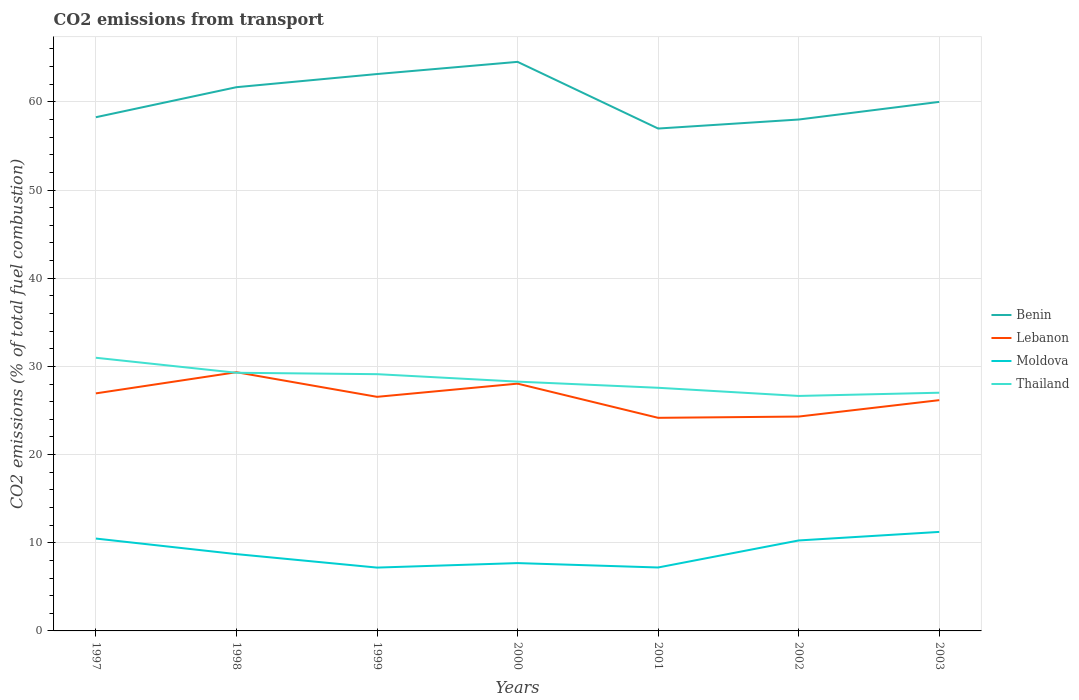How many different coloured lines are there?
Give a very brief answer. 4. Across all years, what is the maximum total CO2 emitted in Benin?
Make the answer very short. 56.98. In which year was the total CO2 emitted in Lebanon maximum?
Give a very brief answer. 2001. What is the total total CO2 emitted in Benin in the graph?
Ensure brevity in your answer.  3.16. What is the difference between the highest and the second highest total CO2 emitted in Benin?
Keep it short and to the point. 7.56. What is the difference between the highest and the lowest total CO2 emitted in Thailand?
Your response must be concise. 3. Is the total CO2 emitted in Thailand strictly greater than the total CO2 emitted in Lebanon over the years?
Your answer should be compact. No. How many years are there in the graph?
Provide a succinct answer. 7. What is the difference between two consecutive major ticks on the Y-axis?
Give a very brief answer. 10. Are the values on the major ticks of Y-axis written in scientific E-notation?
Give a very brief answer. No. Does the graph contain any zero values?
Give a very brief answer. No. Does the graph contain grids?
Your answer should be compact. Yes. Where does the legend appear in the graph?
Your response must be concise. Center right. How many legend labels are there?
Give a very brief answer. 4. What is the title of the graph?
Provide a short and direct response. CO2 emissions from transport. What is the label or title of the Y-axis?
Give a very brief answer. CO2 emissions (% of total fuel combustion). What is the CO2 emissions (% of total fuel combustion) of Benin in 1997?
Keep it short and to the point. 58.26. What is the CO2 emissions (% of total fuel combustion) in Lebanon in 1997?
Keep it short and to the point. 26.94. What is the CO2 emissions (% of total fuel combustion) of Moldova in 1997?
Provide a short and direct response. 10.48. What is the CO2 emissions (% of total fuel combustion) in Thailand in 1997?
Give a very brief answer. 30.98. What is the CO2 emissions (% of total fuel combustion) in Benin in 1998?
Your response must be concise. 61.67. What is the CO2 emissions (% of total fuel combustion) in Lebanon in 1998?
Give a very brief answer. 29.34. What is the CO2 emissions (% of total fuel combustion) in Moldova in 1998?
Your answer should be compact. 8.71. What is the CO2 emissions (% of total fuel combustion) in Thailand in 1998?
Make the answer very short. 29.28. What is the CO2 emissions (% of total fuel combustion) of Benin in 1999?
Your answer should be very brief. 63.16. What is the CO2 emissions (% of total fuel combustion) in Lebanon in 1999?
Provide a succinct answer. 26.55. What is the CO2 emissions (% of total fuel combustion) of Moldova in 1999?
Ensure brevity in your answer.  7.18. What is the CO2 emissions (% of total fuel combustion) in Thailand in 1999?
Ensure brevity in your answer.  29.12. What is the CO2 emissions (% of total fuel combustion) in Benin in 2000?
Your response must be concise. 64.54. What is the CO2 emissions (% of total fuel combustion) in Lebanon in 2000?
Ensure brevity in your answer.  28.05. What is the CO2 emissions (% of total fuel combustion) in Moldova in 2000?
Ensure brevity in your answer.  7.69. What is the CO2 emissions (% of total fuel combustion) in Thailand in 2000?
Provide a short and direct response. 28.27. What is the CO2 emissions (% of total fuel combustion) of Benin in 2001?
Make the answer very short. 56.98. What is the CO2 emissions (% of total fuel combustion) of Lebanon in 2001?
Offer a terse response. 24.17. What is the CO2 emissions (% of total fuel combustion) in Moldova in 2001?
Your answer should be very brief. 7.2. What is the CO2 emissions (% of total fuel combustion) of Thailand in 2001?
Your response must be concise. 27.58. What is the CO2 emissions (% of total fuel combustion) in Lebanon in 2002?
Provide a succinct answer. 24.31. What is the CO2 emissions (% of total fuel combustion) in Moldova in 2002?
Ensure brevity in your answer.  10.26. What is the CO2 emissions (% of total fuel combustion) of Thailand in 2002?
Your answer should be compact. 26.65. What is the CO2 emissions (% of total fuel combustion) of Lebanon in 2003?
Make the answer very short. 26.17. What is the CO2 emissions (% of total fuel combustion) in Moldova in 2003?
Offer a terse response. 11.23. What is the CO2 emissions (% of total fuel combustion) of Thailand in 2003?
Give a very brief answer. 27.02. Across all years, what is the maximum CO2 emissions (% of total fuel combustion) in Benin?
Make the answer very short. 64.54. Across all years, what is the maximum CO2 emissions (% of total fuel combustion) in Lebanon?
Offer a terse response. 29.34. Across all years, what is the maximum CO2 emissions (% of total fuel combustion) of Moldova?
Offer a very short reply. 11.23. Across all years, what is the maximum CO2 emissions (% of total fuel combustion) of Thailand?
Ensure brevity in your answer.  30.98. Across all years, what is the minimum CO2 emissions (% of total fuel combustion) of Benin?
Provide a short and direct response. 56.98. Across all years, what is the minimum CO2 emissions (% of total fuel combustion) of Lebanon?
Your answer should be compact. 24.17. Across all years, what is the minimum CO2 emissions (% of total fuel combustion) in Moldova?
Offer a terse response. 7.18. Across all years, what is the minimum CO2 emissions (% of total fuel combustion) in Thailand?
Keep it short and to the point. 26.65. What is the total CO2 emissions (% of total fuel combustion) of Benin in the graph?
Give a very brief answer. 422.6. What is the total CO2 emissions (% of total fuel combustion) of Lebanon in the graph?
Make the answer very short. 185.53. What is the total CO2 emissions (% of total fuel combustion) in Moldova in the graph?
Give a very brief answer. 62.75. What is the total CO2 emissions (% of total fuel combustion) in Thailand in the graph?
Give a very brief answer. 198.89. What is the difference between the CO2 emissions (% of total fuel combustion) of Benin in 1997 and that in 1998?
Your answer should be very brief. -3.41. What is the difference between the CO2 emissions (% of total fuel combustion) in Lebanon in 1997 and that in 1998?
Your answer should be very brief. -2.4. What is the difference between the CO2 emissions (% of total fuel combustion) of Moldova in 1997 and that in 1998?
Your response must be concise. 1.76. What is the difference between the CO2 emissions (% of total fuel combustion) of Thailand in 1997 and that in 1998?
Your answer should be compact. 1.7. What is the difference between the CO2 emissions (% of total fuel combustion) of Benin in 1997 and that in 1999?
Offer a terse response. -4.9. What is the difference between the CO2 emissions (% of total fuel combustion) of Lebanon in 1997 and that in 1999?
Provide a short and direct response. 0.39. What is the difference between the CO2 emissions (% of total fuel combustion) of Moldova in 1997 and that in 1999?
Offer a terse response. 3.29. What is the difference between the CO2 emissions (% of total fuel combustion) of Thailand in 1997 and that in 1999?
Offer a very short reply. 1.86. What is the difference between the CO2 emissions (% of total fuel combustion) of Benin in 1997 and that in 2000?
Your answer should be very brief. -6.28. What is the difference between the CO2 emissions (% of total fuel combustion) in Lebanon in 1997 and that in 2000?
Your answer should be compact. -1.1. What is the difference between the CO2 emissions (% of total fuel combustion) of Moldova in 1997 and that in 2000?
Your answer should be compact. 2.78. What is the difference between the CO2 emissions (% of total fuel combustion) in Thailand in 1997 and that in 2000?
Provide a short and direct response. 2.71. What is the difference between the CO2 emissions (% of total fuel combustion) in Benin in 1997 and that in 2001?
Make the answer very short. 1.28. What is the difference between the CO2 emissions (% of total fuel combustion) of Lebanon in 1997 and that in 2001?
Ensure brevity in your answer.  2.77. What is the difference between the CO2 emissions (% of total fuel combustion) in Moldova in 1997 and that in 2001?
Give a very brief answer. 3.28. What is the difference between the CO2 emissions (% of total fuel combustion) of Thailand in 1997 and that in 2001?
Your answer should be very brief. 3.4. What is the difference between the CO2 emissions (% of total fuel combustion) of Benin in 1997 and that in 2002?
Provide a succinct answer. 0.26. What is the difference between the CO2 emissions (% of total fuel combustion) in Lebanon in 1997 and that in 2002?
Provide a short and direct response. 2.63. What is the difference between the CO2 emissions (% of total fuel combustion) in Moldova in 1997 and that in 2002?
Offer a very short reply. 0.21. What is the difference between the CO2 emissions (% of total fuel combustion) of Thailand in 1997 and that in 2002?
Make the answer very short. 4.33. What is the difference between the CO2 emissions (% of total fuel combustion) of Benin in 1997 and that in 2003?
Offer a very short reply. -1.74. What is the difference between the CO2 emissions (% of total fuel combustion) of Lebanon in 1997 and that in 2003?
Your answer should be very brief. 0.77. What is the difference between the CO2 emissions (% of total fuel combustion) of Moldova in 1997 and that in 2003?
Give a very brief answer. -0.75. What is the difference between the CO2 emissions (% of total fuel combustion) in Thailand in 1997 and that in 2003?
Offer a terse response. 3.96. What is the difference between the CO2 emissions (% of total fuel combustion) in Benin in 1998 and that in 1999?
Offer a terse response. -1.49. What is the difference between the CO2 emissions (% of total fuel combustion) of Lebanon in 1998 and that in 1999?
Make the answer very short. 2.79. What is the difference between the CO2 emissions (% of total fuel combustion) of Moldova in 1998 and that in 1999?
Provide a short and direct response. 1.53. What is the difference between the CO2 emissions (% of total fuel combustion) of Thailand in 1998 and that in 1999?
Make the answer very short. 0.16. What is the difference between the CO2 emissions (% of total fuel combustion) of Benin in 1998 and that in 2000?
Provide a short and direct response. -2.87. What is the difference between the CO2 emissions (% of total fuel combustion) of Lebanon in 1998 and that in 2000?
Your response must be concise. 1.3. What is the difference between the CO2 emissions (% of total fuel combustion) of Moldova in 1998 and that in 2000?
Offer a very short reply. 1.02. What is the difference between the CO2 emissions (% of total fuel combustion) in Thailand in 1998 and that in 2000?
Offer a terse response. 1. What is the difference between the CO2 emissions (% of total fuel combustion) of Benin in 1998 and that in 2001?
Offer a terse response. 4.69. What is the difference between the CO2 emissions (% of total fuel combustion) of Lebanon in 1998 and that in 2001?
Your response must be concise. 5.17. What is the difference between the CO2 emissions (% of total fuel combustion) of Moldova in 1998 and that in 2001?
Give a very brief answer. 1.52. What is the difference between the CO2 emissions (% of total fuel combustion) of Thailand in 1998 and that in 2001?
Provide a short and direct response. 1.7. What is the difference between the CO2 emissions (% of total fuel combustion) in Benin in 1998 and that in 2002?
Keep it short and to the point. 3.67. What is the difference between the CO2 emissions (% of total fuel combustion) in Lebanon in 1998 and that in 2002?
Ensure brevity in your answer.  5.03. What is the difference between the CO2 emissions (% of total fuel combustion) of Moldova in 1998 and that in 2002?
Offer a very short reply. -1.55. What is the difference between the CO2 emissions (% of total fuel combustion) in Thailand in 1998 and that in 2002?
Your response must be concise. 2.63. What is the difference between the CO2 emissions (% of total fuel combustion) in Lebanon in 1998 and that in 2003?
Offer a very short reply. 3.17. What is the difference between the CO2 emissions (% of total fuel combustion) of Moldova in 1998 and that in 2003?
Ensure brevity in your answer.  -2.52. What is the difference between the CO2 emissions (% of total fuel combustion) in Thailand in 1998 and that in 2003?
Make the answer very short. 2.26. What is the difference between the CO2 emissions (% of total fuel combustion) of Benin in 1999 and that in 2000?
Your response must be concise. -1.38. What is the difference between the CO2 emissions (% of total fuel combustion) in Lebanon in 1999 and that in 2000?
Provide a succinct answer. -1.5. What is the difference between the CO2 emissions (% of total fuel combustion) of Moldova in 1999 and that in 2000?
Make the answer very short. -0.51. What is the difference between the CO2 emissions (% of total fuel combustion) in Thailand in 1999 and that in 2000?
Your answer should be compact. 0.85. What is the difference between the CO2 emissions (% of total fuel combustion) in Benin in 1999 and that in 2001?
Provide a succinct answer. 6.18. What is the difference between the CO2 emissions (% of total fuel combustion) in Lebanon in 1999 and that in 2001?
Your answer should be very brief. 2.38. What is the difference between the CO2 emissions (% of total fuel combustion) in Moldova in 1999 and that in 2001?
Your response must be concise. -0.01. What is the difference between the CO2 emissions (% of total fuel combustion) in Thailand in 1999 and that in 2001?
Keep it short and to the point. 1.54. What is the difference between the CO2 emissions (% of total fuel combustion) of Benin in 1999 and that in 2002?
Offer a very short reply. 5.16. What is the difference between the CO2 emissions (% of total fuel combustion) in Lebanon in 1999 and that in 2002?
Your response must be concise. 2.24. What is the difference between the CO2 emissions (% of total fuel combustion) of Moldova in 1999 and that in 2002?
Ensure brevity in your answer.  -3.08. What is the difference between the CO2 emissions (% of total fuel combustion) of Thailand in 1999 and that in 2002?
Your answer should be compact. 2.47. What is the difference between the CO2 emissions (% of total fuel combustion) of Benin in 1999 and that in 2003?
Provide a short and direct response. 3.16. What is the difference between the CO2 emissions (% of total fuel combustion) in Lebanon in 1999 and that in 2003?
Your answer should be very brief. 0.38. What is the difference between the CO2 emissions (% of total fuel combustion) of Moldova in 1999 and that in 2003?
Provide a short and direct response. -4.05. What is the difference between the CO2 emissions (% of total fuel combustion) in Thailand in 1999 and that in 2003?
Give a very brief answer. 2.1. What is the difference between the CO2 emissions (% of total fuel combustion) of Benin in 2000 and that in 2001?
Ensure brevity in your answer.  7.56. What is the difference between the CO2 emissions (% of total fuel combustion) in Lebanon in 2000 and that in 2001?
Give a very brief answer. 3.88. What is the difference between the CO2 emissions (% of total fuel combustion) in Moldova in 2000 and that in 2001?
Offer a terse response. 0.5. What is the difference between the CO2 emissions (% of total fuel combustion) in Thailand in 2000 and that in 2001?
Your answer should be compact. 0.7. What is the difference between the CO2 emissions (% of total fuel combustion) in Benin in 2000 and that in 2002?
Keep it short and to the point. 6.54. What is the difference between the CO2 emissions (% of total fuel combustion) of Lebanon in 2000 and that in 2002?
Your answer should be compact. 3.73. What is the difference between the CO2 emissions (% of total fuel combustion) in Moldova in 2000 and that in 2002?
Ensure brevity in your answer.  -2.57. What is the difference between the CO2 emissions (% of total fuel combustion) of Thailand in 2000 and that in 2002?
Offer a terse response. 1.62. What is the difference between the CO2 emissions (% of total fuel combustion) of Benin in 2000 and that in 2003?
Your response must be concise. 4.54. What is the difference between the CO2 emissions (% of total fuel combustion) in Lebanon in 2000 and that in 2003?
Your answer should be very brief. 1.87. What is the difference between the CO2 emissions (% of total fuel combustion) in Moldova in 2000 and that in 2003?
Your response must be concise. -3.54. What is the difference between the CO2 emissions (% of total fuel combustion) in Thailand in 2000 and that in 2003?
Your answer should be very brief. 1.26. What is the difference between the CO2 emissions (% of total fuel combustion) of Benin in 2001 and that in 2002?
Offer a very short reply. -1.02. What is the difference between the CO2 emissions (% of total fuel combustion) of Lebanon in 2001 and that in 2002?
Your answer should be compact. -0.14. What is the difference between the CO2 emissions (% of total fuel combustion) in Moldova in 2001 and that in 2002?
Provide a succinct answer. -3.06. What is the difference between the CO2 emissions (% of total fuel combustion) of Thailand in 2001 and that in 2002?
Your answer should be very brief. 0.93. What is the difference between the CO2 emissions (% of total fuel combustion) of Benin in 2001 and that in 2003?
Your answer should be compact. -3.02. What is the difference between the CO2 emissions (% of total fuel combustion) in Lebanon in 2001 and that in 2003?
Your answer should be compact. -2.01. What is the difference between the CO2 emissions (% of total fuel combustion) of Moldova in 2001 and that in 2003?
Your response must be concise. -4.03. What is the difference between the CO2 emissions (% of total fuel combustion) in Thailand in 2001 and that in 2003?
Provide a short and direct response. 0.56. What is the difference between the CO2 emissions (% of total fuel combustion) in Lebanon in 2002 and that in 2003?
Provide a succinct answer. -1.86. What is the difference between the CO2 emissions (% of total fuel combustion) in Moldova in 2002 and that in 2003?
Offer a terse response. -0.97. What is the difference between the CO2 emissions (% of total fuel combustion) in Thailand in 2002 and that in 2003?
Offer a very short reply. -0.36. What is the difference between the CO2 emissions (% of total fuel combustion) of Benin in 1997 and the CO2 emissions (% of total fuel combustion) of Lebanon in 1998?
Your response must be concise. 28.92. What is the difference between the CO2 emissions (% of total fuel combustion) in Benin in 1997 and the CO2 emissions (% of total fuel combustion) in Moldova in 1998?
Ensure brevity in your answer.  49.55. What is the difference between the CO2 emissions (% of total fuel combustion) of Benin in 1997 and the CO2 emissions (% of total fuel combustion) of Thailand in 1998?
Provide a succinct answer. 28.98. What is the difference between the CO2 emissions (% of total fuel combustion) of Lebanon in 1997 and the CO2 emissions (% of total fuel combustion) of Moldova in 1998?
Your answer should be very brief. 18.23. What is the difference between the CO2 emissions (% of total fuel combustion) in Lebanon in 1997 and the CO2 emissions (% of total fuel combustion) in Thailand in 1998?
Keep it short and to the point. -2.34. What is the difference between the CO2 emissions (% of total fuel combustion) in Moldova in 1997 and the CO2 emissions (% of total fuel combustion) in Thailand in 1998?
Provide a succinct answer. -18.8. What is the difference between the CO2 emissions (% of total fuel combustion) in Benin in 1997 and the CO2 emissions (% of total fuel combustion) in Lebanon in 1999?
Make the answer very short. 31.71. What is the difference between the CO2 emissions (% of total fuel combustion) of Benin in 1997 and the CO2 emissions (% of total fuel combustion) of Moldova in 1999?
Give a very brief answer. 51.08. What is the difference between the CO2 emissions (% of total fuel combustion) in Benin in 1997 and the CO2 emissions (% of total fuel combustion) in Thailand in 1999?
Give a very brief answer. 29.14. What is the difference between the CO2 emissions (% of total fuel combustion) of Lebanon in 1997 and the CO2 emissions (% of total fuel combustion) of Moldova in 1999?
Provide a succinct answer. 19.76. What is the difference between the CO2 emissions (% of total fuel combustion) in Lebanon in 1997 and the CO2 emissions (% of total fuel combustion) in Thailand in 1999?
Your answer should be compact. -2.18. What is the difference between the CO2 emissions (% of total fuel combustion) of Moldova in 1997 and the CO2 emissions (% of total fuel combustion) of Thailand in 1999?
Give a very brief answer. -18.64. What is the difference between the CO2 emissions (% of total fuel combustion) in Benin in 1997 and the CO2 emissions (% of total fuel combustion) in Lebanon in 2000?
Your response must be concise. 30.22. What is the difference between the CO2 emissions (% of total fuel combustion) of Benin in 1997 and the CO2 emissions (% of total fuel combustion) of Moldova in 2000?
Ensure brevity in your answer.  50.57. What is the difference between the CO2 emissions (% of total fuel combustion) in Benin in 1997 and the CO2 emissions (% of total fuel combustion) in Thailand in 2000?
Offer a terse response. 29.99. What is the difference between the CO2 emissions (% of total fuel combustion) of Lebanon in 1997 and the CO2 emissions (% of total fuel combustion) of Moldova in 2000?
Provide a short and direct response. 19.25. What is the difference between the CO2 emissions (% of total fuel combustion) in Lebanon in 1997 and the CO2 emissions (% of total fuel combustion) in Thailand in 2000?
Your answer should be compact. -1.33. What is the difference between the CO2 emissions (% of total fuel combustion) in Moldova in 1997 and the CO2 emissions (% of total fuel combustion) in Thailand in 2000?
Offer a terse response. -17.8. What is the difference between the CO2 emissions (% of total fuel combustion) in Benin in 1997 and the CO2 emissions (% of total fuel combustion) in Lebanon in 2001?
Your answer should be very brief. 34.09. What is the difference between the CO2 emissions (% of total fuel combustion) of Benin in 1997 and the CO2 emissions (% of total fuel combustion) of Moldova in 2001?
Offer a terse response. 51.07. What is the difference between the CO2 emissions (% of total fuel combustion) in Benin in 1997 and the CO2 emissions (% of total fuel combustion) in Thailand in 2001?
Your answer should be very brief. 30.68. What is the difference between the CO2 emissions (% of total fuel combustion) of Lebanon in 1997 and the CO2 emissions (% of total fuel combustion) of Moldova in 2001?
Your answer should be very brief. 19.75. What is the difference between the CO2 emissions (% of total fuel combustion) of Lebanon in 1997 and the CO2 emissions (% of total fuel combustion) of Thailand in 2001?
Your answer should be very brief. -0.64. What is the difference between the CO2 emissions (% of total fuel combustion) in Moldova in 1997 and the CO2 emissions (% of total fuel combustion) in Thailand in 2001?
Offer a very short reply. -17.1. What is the difference between the CO2 emissions (% of total fuel combustion) of Benin in 1997 and the CO2 emissions (% of total fuel combustion) of Lebanon in 2002?
Provide a succinct answer. 33.95. What is the difference between the CO2 emissions (% of total fuel combustion) in Benin in 1997 and the CO2 emissions (% of total fuel combustion) in Moldova in 2002?
Give a very brief answer. 48. What is the difference between the CO2 emissions (% of total fuel combustion) of Benin in 1997 and the CO2 emissions (% of total fuel combustion) of Thailand in 2002?
Keep it short and to the point. 31.61. What is the difference between the CO2 emissions (% of total fuel combustion) in Lebanon in 1997 and the CO2 emissions (% of total fuel combustion) in Moldova in 2002?
Your answer should be compact. 16.68. What is the difference between the CO2 emissions (% of total fuel combustion) in Lebanon in 1997 and the CO2 emissions (% of total fuel combustion) in Thailand in 2002?
Provide a succinct answer. 0.29. What is the difference between the CO2 emissions (% of total fuel combustion) of Moldova in 1997 and the CO2 emissions (% of total fuel combustion) of Thailand in 2002?
Offer a very short reply. -16.18. What is the difference between the CO2 emissions (% of total fuel combustion) in Benin in 1997 and the CO2 emissions (% of total fuel combustion) in Lebanon in 2003?
Give a very brief answer. 32.09. What is the difference between the CO2 emissions (% of total fuel combustion) in Benin in 1997 and the CO2 emissions (% of total fuel combustion) in Moldova in 2003?
Your answer should be compact. 47.03. What is the difference between the CO2 emissions (% of total fuel combustion) of Benin in 1997 and the CO2 emissions (% of total fuel combustion) of Thailand in 2003?
Your answer should be compact. 31.25. What is the difference between the CO2 emissions (% of total fuel combustion) in Lebanon in 1997 and the CO2 emissions (% of total fuel combustion) in Moldova in 2003?
Your answer should be very brief. 15.71. What is the difference between the CO2 emissions (% of total fuel combustion) of Lebanon in 1997 and the CO2 emissions (% of total fuel combustion) of Thailand in 2003?
Provide a succinct answer. -0.07. What is the difference between the CO2 emissions (% of total fuel combustion) in Moldova in 1997 and the CO2 emissions (% of total fuel combustion) in Thailand in 2003?
Your response must be concise. -16.54. What is the difference between the CO2 emissions (% of total fuel combustion) of Benin in 1998 and the CO2 emissions (% of total fuel combustion) of Lebanon in 1999?
Ensure brevity in your answer.  35.12. What is the difference between the CO2 emissions (% of total fuel combustion) in Benin in 1998 and the CO2 emissions (% of total fuel combustion) in Moldova in 1999?
Your answer should be compact. 54.48. What is the difference between the CO2 emissions (% of total fuel combustion) of Benin in 1998 and the CO2 emissions (% of total fuel combustion) of Thailand in 1999?
Your response must be concise. 32.55. What is the difference between the CO2 emissions (% of total fuel combustion) in Lebanon in 1998 and the CO2 emissions (% of total fuel combustion) in Moldova in 1999?
Give a very brief answer. 22.16. What is the difference between the CO2 emissions (% of total fuel combustion) in Lebanon in 1998 and the CO2 emissions (% of total fuel combustion) in Thailand in 1999?
Give a very brief answer. 0.22. What is the difference between the CO2 emissions (% of total fuel combustion) of Moldova in 1998 and the CO2 emissions (% of total fuel combustion) of Thailand in 1999?
Keep it short and to the point. -20.41. What is the difference between the CO2 emissions (% of total fuel combustion) of Benin in 1998 and the CO2 emissions (% of total fuel combustion) of Lebanon in 2000?
Keep it short and to the point. 33.62. What is the difference between the CO2 emissions (% of total fuel combustion) of Benin in 1998 and the CO2 emissions (% of total fuel combustion) of Moldova in 2000?
Provide a short and direct response. 53.97. What is the difference between the CO2 emissions (% of total fuel combustion) of Benin in 1998 and the CO2 emissions (% of total fuel combustion) of Thailand in 2000?
Give a very brief answer. 33.39. What is the difference between the CO2 emissions (% of total fuel combustion) in Lebanon in 1998 and the CO2 emissions (% of total fuel combustion) in Moldova in 2000?
Provide a short and direct response. 21.65. What is the difference between the CO2 emissions (% of total fuel combustion) of Lebanon in 1998 and the CO2 emissions (% of total fuel combustion) of Thailand in 2000?
Provide a succinct answer. 1.07. What is the difference between the CO2 emissions (% of total fuel combustion) in Moldova in 1998 and the CO2 emissions (% of total fuel combustion) in Thailand in 2000?
Offer a very short reply. -19.56. What is the difference between the CO2 emissions (% of total fuel combustion) in Benin in 1998 and the CO2 emissions (% of total fuel combustion) in Lebanon in 2001?
Keep it short and to the point. 37.5. What is the difference between the CO2 emissions (% of total fuel combustion) of Benin in 1998 and the CO2 emissions (% of total fuel combustion) of Moldova in 2001?
Your answer should be compact. 54.47. What is the difference between the CO2 emissions (% of total fuel combustion) of Benin in 1998 and the CO2 emissions (% of total fuel combustion) of Thailand in 2001?
Make the answer very short. 34.09. What is the difference between the CO2 emissions (% of total fuel combustion) in Lebanon in 1998 and the CO2 emissions (% of total fuel combustion) in Moldova in 2001?
Give a very brief answer. 22.15. What is the difference between the CO2 emissions (% of total fuel combustion) of Lebanon in 1998 and the CO2 emissions (% of total fuel combustion) of Thailand in 2001?
Keep it short and to the point. 1.77. What is the difference between the CO2 emissions (% of total fuel combustion) in Moldova in 1998 and the CO2 emissions (% of total fuel combustion) in Thailand in 2001?
Make the answer very short. -18.86. What is the difference between the CO2 emissions (% of total fuel combustion) of Benin in 1998 and the CO2 emissions (% of total fuel combustion) of Lebanon in 2002?
Your response must be concise. 37.35. What is the difference between the CO2 emissions (% of total fuel combustion) in Benin in 1998 and the CO2 emissions (% of total fuel combustion) in Moldova in 2002?
Keep it short and to the point. 51.41. What is the difference between the CO2 emissions (% of total fuel combustion) in Benin in 1998 and the CO2 emissions (% of total fuel combustion) in Thailand in 2002?
Provide a succinct answer. 35.02. What is the difference between the CO2 emissions (% of total fuel combustion) of Lebanon in 1998 and the CO2 emissions (% of total fuel combustion) of Moldova in 2002?
Offer a very short reply. 19.08. What is the difference between the CO2 emissions (% of total fuel combustion) in Lebanon in 1998 and the CO2 emissions (% of total fuel combustion) in Thailand in 2002?
Your answer should be very brief. 2.69. What is the difference between the CO2 emissions (% of total fuel combustion) of Moldova in 1998 and the CO2 emissions (% of total fuel combustion) of Thailand in 2002?
Make the answer very short. -17.94. What is the difference between the CO2 emissions (% of total fuel combustion) in Benin in 1998 and the CO2 emissions (% of total fuel combustion) in Lebanon in 2003?
Provide a short and direct response. 35.49. What is the difference between the CO2 emissions (% of total fuel combustion) of Benin in 1998 and the CO2 emissions (% of total fuel combustion) of Moldova in 2003?
Your answer should be compact. 50.44. What is the difference between the CO2 emissions (% of total fuel combustion) of Benin in 1998 and the CO2 emissions (% of total fuel combustion) of Thailand in 2003?
Give a very brief answer. 34.65. What is the difference between the CO2 emissions (% of total fuel combustion) in Lebanon in 1998 and the CO2 emissions (% of total fuel combustion) in Moldova in 2003?
Your response must be concise. 18.11. What is the difference between the CO2 emissions (% of total fuel combustion) of Lebanon in 1998 and the CO2 emissions (% of total fuel combustion) of Thailand in 2003?
Offer a terse response. 2.33. What is the difference between the CO2 emissions (% of total fuel combustion) of Moldova in 1998 and the CO2 emissions (% of total fuel combustion) of Thailand in 2003?
Provide a succinct answer. -18.3. What is the difference between the CO2 emissions (% of total fuel combustion) of Benin in 1999 and the CO2 emissions (% of total fuel combustion) of Lebanon in 2000?
Keep it short and to the point. 35.11. What is the difference between the CO2 emissions (% of total fuel combustion) of Benin in 1999 and the CO2 emissions (% of total fuel combustion) of Moldova in 2000?
Your answer should be compact. 55.47. What is the difference between the CO2 emissions (% of total fuel combustion) of Benin in 1999 and the CO2 emissions (% of total fuel combustion) of Thailand in 2000?
Give a very brief answer. 34.88. What is the difference between the CO2 emissions (% of total fuel combustion) in Lebanon in 1999 and the CO2 emissions (% of total fuel combustion) in Moldova in 2000?
Give a very brief answer. 18.86. What is the difference between the CO2 emissions (% of total fuel combustion) in Lebanon in 1999 and the CO2 emissions (% of total fuel combustion) in Thailand in 2000?
Keep it short and to the point. -1.72. What is the difference between the CO2 emissions (% of total fuel combustion) of Moldova in 1999 and the CO2 emissions (% of total fuel combustion) of Thailand in 2000?
Offer a terse response. -21.09. What is the difference between the CO2 emissions (% of total fuel combustion) of Benin in 1999 and the CO2 emissions (% of total fuel combustion) of Lebanon in 2001?
Give a very brief answer. 38.99. What is the difference between the CO2 emissions (% of total fuel combustion) of Benin in 1999 and the CO2 emissions (% of total fuel combustion) of Moldova in 2001?
Your answer should be very brief. 55.96. What is the difference between the CO2 emissions (% of total fuel combustion) of Benin in 1999 and the CO2 emissions (% of total fuel combustion) of Thailand in 2001?
Offer a very short reply. 35.58. What is the difference between the CO2 emissions (% of total fuel combustion) of Lebanon in 1999 and the CO2 emissions (% of total fuel combustion) of Moldova in 2001?
Make the answer very short. 19.35. What is the difference between the CO2 emissions (% of total fuel combustion) in Lebanon in 1999 and the CO2 emissions (% of total fuel combustion) in Thailand in 2001?
Provide a succinct answer. -1.03. What is the difference between the CO2 emissions (% of total fuel combustion) in Moldova in 1999 and the CO2 emissions (% of total fuel combustion) in Thailand in 2001?
Give a very brief answer. -20.39. What is the difference between the CO2 emissions (% of total fuel combustion) in Benin in 1999 and the CO2 emissions (% of total fuel combustion) in Lebanon in 2002?
Ensure brevity in your answer.  38.85. What is the difference between the CO2 emissions (% of total fuel combustion) of Benin in 1999 and the CO2 emissions (% of total fuel combustion) of Moldova in 2002?
Your answer should be very brief. 52.9. What is the difference between the CO2 emissions (% of total fuel combustion) in Benin in 1999 and the CO2 emissions (% of total fuel combustion) in Thailand in 2002?
Your answer should be compact. 36.51. What is the difference between the CO2 emissions (% of total fuel combustion) in Lebanon in 1999 and the CO2 emissions (% of total fuel combustion) in Moldova in 2002?
Provide a short and direct response. 16.29. What is the difference between the CO2 emissions (% of total fuel combustion) of Lebanon in 1999 and the CO2 emissions (% of total fuel combustion) of Thailand in 2002?
Offer a very short reply. -0.1. What is the difference between the CO2 emissions (% of total fuel combustion) in Moldova in 1999 and the CO2 emissions (% of total fuel combustion) in Thailand in 2002?
Your answer should be compact. -19.47. What is the difference between the CO2 emissions (% of total fuel combustion) in Benin in 1999 and the CO2 emissions (% of total fuel combustion) in Lebanon in 2003?
Offer a terse response. 36.98. What is the difference between the CO2 emissions (% of total fuel combustion) in Benin in 1999 and the CO2 emissions (% of total fuel combustion) in Moldova in 2003?
Make the answer very short. 51.93. What is the difference between the CO2 emissions (% of total fuel combustion) of Benin in 1999 and the CO2 emissions (% of total fuel combustion) of Thailand in 2003?
Keep it short and to the point. 36.14. What is the difference between the CO2 emissions (% of total fuel combustion) of Lebanon in 1999 and the CO2 emissions (% of total fuel combustion) of Moldova in 2003?
Make the answer very short. 15.32. What is the difference between the CO2 emissions (% of total fuel combustion) in Lebanon in 1999 and the CO2 emissions (% of total fuel combustion) in Thailand in 2003?
Your answer should be compact. -0.47. What is the difference between the CO2 emissions (% of total fuel combustion) in Moldova in 1999 and the CO2 emissions (% of total fuel combustion) in Thailand in 2003?
Provide a short and direct response. -19.83. What is the difference between the CO2 emissions (% of total fuel combustion) of Benin in 2000 and the CO2 emissions (% of total fuel combustion) of Lebanon in 2001?
Offer a very short reply. 40.37. What is the difference between the CO2 emissions (% of total fuel combustion) in Benin in 2000 and the CO2 emissions (% of total fuel combustion) in Moldova in 2001?
Your answer should be very brief. 57.34. What is the difference between the CO2 emissions (% of total fuel combustion) in Benin in 2000 and the CO2 emissions (% of total fuel combustion) in Thailand in 2001?
Offer a very short reply. 36.96. What is the difference between the CO2 emissions (% of total fuel combustion) in Lebanon in 2000 and the CO2 emissions (% of total fuel combustion) in Moldova in 2001?
Your answer should be compact. 20.85. What is the difference between the CO2 emissions (% of total fuel combustion) in Lebanon in 2000 and the CO2 emissions (% of total fuel combustion) in Thailand in 2001?
Your answer should be compact. 0.47. What is the difference between the CO2 emissions (% of total fuel combustion) in Moldova in 2000 and the CO2 emissions (% of total fuel combustion) in Thailand in 2001?
Ensure brevity in your answer.  -19.88. What is the difference between the CO2 emissions (% of total fuel combustion) in Benin in 2000 and the CO2 emissions (% of total fuel combustion) in Lebanon in 2002?
Provide a short and direct response. 40.23. What is the difference between the CO2 emissions (% of total fuel combustion) in Benin in 2000 and the CO2 emissions (% of total fuel combustion) in Moldova in 2002?
Give a very brief answer. 54.28. What is the difference between the CO2 emissions (% of total fuel combustion) of Benin in 2000 and the CO2 emissions (% of total fuel combustion) of Thailand in 2002?
Provide a succinct answer. 37.89. What is the difference between the CO2 emissions (% of total fuel combustion) of Lebanon in 2000 and the CO2 emissions (% of total fuel combustion) of Moldova in 2002?
Provide a short and direct response. 17.79. What is the difference between the CO2 emissions (% of total fuel combustion) of Lebanon in 2000 and the CO2 emissions (% of total fuel combustion) of Thailand in 2002?
Your response must be concise. 1.39. What is the difference between the CO2 emissions (% of total fuel combustion) of Moldova in 2000 and the CO2 emissions (% of total fuel combustion) of Thailand in 2002?
Offer a terse response. -18.96. What is the difference between the CO2 emissions (% of total fuel combustion) in Benin in 2000 and the CO2 emissions (% of total fuel combustion) in Lebanon in 2003?
Keep it short and to the point. 38.37. What is the difference between the CO2 emissions (% of total fuel combustion) in Benin in 2000 and the CO2 emissions (% of total fuel combustion) in Moldova in 2003?
Your response must be concise. 53.31. What is the difference between the CO2 emissions (% of total fuel combustion) of Benin in 2000 and the CO2 emissions (% of total fuel combustion) of Thailand in 2003?
Ensure brevity in your answer.  37.52. What is the difference between the CO2 emissions (% of total fuel combustion) of Lebanon in 2000 and the CO2 emissions (% of total fuel combustion) of Moldova in 2003?
Your answer should be compact. 16.82. What is the difference between the CO2 emissions (% of total fuel combustion) of Lebanon in 2000 and the CO2 emissions (% of total fuel combustion) of Thailand in 2003?
Make the answer very short. 1.03. What is the difference between the CO2 emissions (% of total fuel combustion) in Moldova in 2000 and the CO2 emissions (% of total fuel combustion) in Thailand in 2003?
Keep it short and to the point. -19.32. What is the difference between the CO2 emissions (% of total fuel combustion) in Benin in 2001 and the CO2 emissions (% of total fuel combustion) in Lebanon in 2002?
Offer a very short reply. 32.66. What is the difference between the CO2 emissions (% of total fuel combustion) in Benin in 2001 and the CO2 emissions (% of total fuel combustion) in Moldova in 2002?
Offer a terse response. 46.72. What is the difference between the CO2 emissions (% of total fuel combustion) in Benin in 2001 and the CO2 emissions (% of total fuel combustion) in Thailand in 2002?
Your answer should be compact. 30.33. What is the difference between the CO2 emissions (% of total fuel combustion) in Lebanon in 2001 and the CO2 emissions (% of total fuel combustion) in Moldova in 2002?
Offer a terse response. 13.91. What is the difference between the CO2 emissions (% of total fuel combustion) in Lebanon in 2001 and the CO2 emissions (% of total fuel combustion) in Thailand in 2002?
Keep it short and to the point. -2.48. What is the difference between the CO2 emissions (% of total fuel combustion) of Moldova in 2001 and the CO2 emissions (% of total fuel combustion) of Thailand in 2002?
Give a very brief answer. -19.46. What is the difference between the CO2 emissions (% of total fuel combustion) in Benin in 2001 and the CO2 emissions (% of total fuel combustion) in Lebanon in 2003?
Make the answer very short. 30.8. What is the difference between the CO2 emissions (% of total fuel combustion) in Benin in 2001 and the CO2 emissions (% of total fuel combustion) in Moldova in 2003?
Keep it short and to the point. 45.75. What is the difference between the CO2 emissions (% of total fuel combustion) of Benin in 2001 and the CO2 emissions (% of total fuel combustion) of Thailand in 2003?
Keep it short and to the point. 29.96. What is the difference between the CO2 emissions (% of total fuel combustion) in Lebanon in 2001 and the CO2 emissions (% of total fuel combustion) in Moldova in 2003?
Provide a succinct answer. 12.94. What is the difference between the CO2 emissions (% of total fuel combustion) of Lebanon in 2001 and the CO2 emissions (% of total fuel combustion) of Thailand in 2003?
Provide a short and direct response. -2.85. What is the difference between the CO2 emissions (% of total fuel combustion) in Moldova in 2001 and the CO2 emissions (% of total fuel combustion) in Thailand in 2003?
Provide a short and direct response. -19.82. What is the difference between the CO2 emissions (% of total fuel combustion) of Benin in 2002 and the CO2 emissions (% of total fuel combustion) of Lebanon in 2003?
Provide a succinct answer. 31.83. What is the difference between the CO2 emissions (% of total fuel combustion) in Benin in 2002 and the CO2 emissions (% of total fuel combustion) in Moldova in 2003?
Offer a very short reply. 46.77. What is the difference between the CO2 emissions (% of total fuel combustion) of Benin in 2002 and the CO2 emissions (% of total fuel combustion) of Thailand in 2003?
Provide a succinct answer. 30.98. What is the difference between the CO2 emissions (% of total fuel combustion) of Lebanon in 2002 and the CO2 emissions (% of total fuel combustion) of Moldova in 2003?
Your response must be concise. 13.08. What is the difference between the CO2 emissions (% of total fuel combustion) in Lebanon in 2002 and the CO2 emissions (% of total fuel combustion) in Thailand in 2003?
Ensure brevity in your answer.  -2.7. What is the difference between the CO2 emissions (% of total fuel combustion) in Moldova in 2002 and the CO2 emissions (% of total fuel combustion) in Thailand in 2003?
Your answer should be compact. -16.76. What is the average CO2 emissions (% of total fuel combustion) of Benin per year?
Provide a short and direct response. 60.37. What is the average CO2 emissions (% of total fuel combustion) of Lebanon per year?
Provide a short and direct response. 26.5. What is the average CO2 emissions (% of total fuel combustion) of Moldova per year?
Offer a terse response. 8.96. What is the average CO2 emissions (% of total fuel combustion) in Thailand per year?
Offer a terse response. 28.41. In the year 1997, what is the difference between the CO2 emissions (% of total fuel combustion) of Benin and CO2 emissions (% of total fuel combustion) of Lebanon?
Your answer should be compact. 31.32. In the year 1997, what is the difference between the CO2 emissions (% of total fuel combustion) in Benin and CO2 emissions (% of total fuel combustion) in Moldova?
Make the answer very short. 47.79. In the year 1997, what is the difference between the CO2 emissions (% of total fuel combustion) in Benin and CO2 emissions (% of total fuel combustion) in Thailand?
Give a very brief answer. 27.28. In the year 1997, what is the difference between the CO2 emissions (% of total fuel combustion) in Lebanon and CO2 emissions (% of total fuel combustion) in Moldova?
Make the answer very short. 16.47. In the year 1997, what is the difference between the CO2 emissions (% of total fuel combustion) in Lebanon and CO2 emissions (% of total fuel combustion) in Thailand?
Offer a terse response. -4.04. In the year 1997, what is the difference between the CO2 emissions (% of total fuel combustion) of Moldova and CO2 emissions (% of total fuel combustion) of Thailand?
Offer a terse response. -20.5. In the year 1998, what is the difference between the CO2 emissions (% of total fuel combustion) in Benin and CO2 emissions (% of total fuel combustion) in Lebanon?
Your answer should be compact. 32.33. In the year 1998, what is the difference between the CO2 emissions (% of total fuel combustion) in Benin and CO2 emissions (% of total fuel combustion) in Moldova?
Offer a terse response. 52.96. In the year 1998, what is the difference between the CO2 emissions (% of total fuel combustion) of Benin and CO2 emissions (% of total fuel combustion) of Thailand?
Make the answer very short. 32.39. In the year 1998, what is the difference between the CO2 emissions (% of total fuel combustion) of Lebanon and CO2 emissions (% of total fuel combustion) of Moldova?
Make the answer very short. 20.63. In the year 1998, what is the difference between the CO2 emissions (% of total fuel combustion) in Lebanon and CO2 emissions (% of total fuel combustion) in Thailand?
Make the answer very short. 0.06. In the year 1998, what is the difference between the CO2 emissions (% of total fuel combustion) of Moldova and CO2 emissions (% of total fuel combustion) of Thailand?
Give a very brief answer. -20.57. In the year 1999, what is the difference between the CO2 emissions (% of total fuel combustion) of Benin and CO2 emissions (% of total fuel combustion) of Lebanon?
Offer a terse response. 36.61. In the year 1999, what is the difference between the CO2 emissions (% of total fuel combustion) of Benin and CO2 emissions (% of total fuel combustion) of Moldova?
Your answer should be compact. 55.97. In the year 1999, what is the difference between the CO2 emissions (% of total fuel combustion) in Benin and CO2 emissions (% of total fuel combustion) in Thailand?
Provide a succinct answer. 34.04. In the year 1999, what is the difference between the CO2 emissions (% of total fuel combustion) in Lebanon and CO2 emissions (% of total fuel combustion) in Moldova?
Provide a short and direct response. 19.37. In the year 1999, what is the difference between the CO2 emissions (% of total fuel combustion) of Lebanon and CO2 emissions (% of total fuel combustion) of Thailand?
Offer a terse response. -2.57. In the year 1999, what is the difference between the CO2 emissions (% of total fuel combustion) of Moldova and CO2 emissions (% of total fuel combustion) of Thailand?
Offer a terse response. -21.94. In the year 2000, what is the difference between the CO2 emissions (% of total fuel combustion) of Benin and CO2 emissions (% of total fuel combustion) of Lebanon?
Your answer should be compact. 36.49. In the year 2000, what is the difference between the CO2 emissions (% of total fuel combustion) of Benin and CO2 emissions (% of total fuel combustion) of Moldova?
Provide a short and direct response. 56.85. In the year 2000, what is the difference between the CO2 emissions (% of total fuel combustion) of Benin and CO2 emissions (% of total fuel combustion) of Thailand?
Keep it short and to the point. 36.27. In the year 2000, what is the difference between the CO2 emissions (% of total fuel combustion) in Lebanon and CO2 emissions (% of total fuel combustion) in Moldova?
Provide a short and direct response. 20.35. In the year 2000, what is the difference between the CO2 emissions (% of total fuel combustion) of Lebanon and CO2 emissions (% of total fuel combustion) of Thailand?
Offer a very short reply. -0.23. In the year 2000, what is the difference between the CO2 emissions (% of total fuel combustion) in Moldova and CO2 emissions (% of total fuel combustion) in Thailand?
Your response must be concise. -20.58. In the year 2001, what is the difference between the CO2 emissions (% of total fuel combustion) of Benin and CO2 emissions (% of total fuel combustion) of Lebanon?
Make the answer very short. 32.81. In the year 2001, what is the difference between the CO2 emissions (% of total fuel combustion) of Benin and CO2 emissions (% of total fuel combustion) of Moldova?
Your answer should be compact. 49.78. In the year 2001, what is the difference between the CO2 emissions (% of total fuel combustion) of Benin and CO2 emissions (% of total fuel combustion) of Thailand?
Provide a short and direct response. 29.4. In the year 2001, what is the difference between the CO2 emissions (% of total fuel combustion) of Lebanon and CO2 emissions (% of total fuel combustion) of Moldova?
Keep it short and to the point. 16.97. In the year 2001, what is the difference between the CO2 emissions (% of total fuel combustion) in Lebanon and CO2 emissions (% of total fuel combustion) in Thailand?
Make the answer very short. -3.41. In the year 2001, what is the difference between the CO2 emissions (% of total fuel combustion) of Moldova and CO2 emissions (% of total fuel combustion) of Thailand?
Your answer should be compact. -20.38. In the year 2002, what is the difference between the CO2 emissions (% of total fuel combustion) in Benin and CO2 emissions (% of total fuel combustion) in Lebanon?
Your answer should be very brief. 33.69. In the year 2002, what is the difference between the CO2 emissions (% of total fuel combustion) of Benin and CO2 emissions (% of total fuel combustion) of Moldova?
Give a very brief answer. 47.74. In the year 2002, what is the difference between the CO2 emissions (% of total fuel combustion) of Benin and CO2 emissions (% of total fuel combustion) of Thailand?
Ensure brevity in your answer.  31.35. In the year 2002, what is the difference between the CO2 emissions (% of total fuel combustion) of Lebanon and CO2 emissions (% of total fuel combustion) of Moldova?
Your answer should be very brief. 14.05. In the year 2002, what is the difference between the CO2 emissions (% of total fuel combustion) of Lebanon and CO2 emissions (% of total fuel combustion) of Thailand?
Give a very brief answer. -2.34. In the year 2002, what is the difference between the CO2 emissions (% of total fuel combustion) of Moldova and CO2 emissions (% of total fuel combustion) of Thailand?
Your response must be concise. -16.39. In the year 2003, what is the difference between the CO2 emissions (% of total fuel combustion) of Benin and CO2 emissions (% of total fuel combustion) of Lebanon?
Offer a very short reply. 33.83. In the year 2003, what is the difference between the CO2 emissions (% of total fuel combustion) in Benin and CO2 emissions (% of total fuel combustion) in Moldova?
Keep it short and to the point. 48.77. In the year 2003, what is the difference between the CO2 emissions (% of total fuel combustion) of Benin and CO2 emissions (% of total fuel combustion) of Thailand?
Provide a short and direct response. 32.98. In the year 2003, what is the difference between the CO2 emissions (% of total fuel combustion) in Lebanon and CO2 emissions (% of total fuel combustion) in Moldova?
Ensure brevity in your answer.  14.94. In the year 2003, what is the difference between the CO2 emissions (% of total fuel combustion) in Lebanon and CO2 emissions (% of total fuel combustion) in Thailand?
Provide a succinct answer. -0.84. In the year 2003, what is the difference between the CO2 emissions (% of total fuel combustion) in Moldova and CO2 emissions (% of total fuel combustion) in Thailand?
Keep it short and to the point. -15.79. What is the ratio of the CO2 emissions (% of total fuel combustion) in Benin in 1997 to that in 1998?
Make the answer very short. 0.94. What is the ratio of the CO2 emissions (% of total fuel combustion) of Lebanon in 1997 to that in 1998?
Make the answer very short. 0.92. What is the ratio of the CO2 emissions (% of total fuel combustion) of Moldova in 1997 to that in 1998?
Your response must be concise. 1.2. What is the ratio of the CO2 emissions (% of total fuel combustion) of Thailand in 1997 to that in 1998?
Provide a succinct answer. 1.06. What is the ratio of the CO2 emissions (% of total fuel combustion) of Benin in 1997 to that in 1999?
Give a very brief answer. 0.92. What is the ratio of the CO2 emissions (% of total fuel combustion) of Lebanon in 1997 to that in 1999?
Your response must be concise. 1.01. What is the ratio of the CO2 emissions (% of total fuel combustion) of Moldova in 1997 to that in 1999?
Your answer should be very brief. 1.46. What is the ratio of the CO2 emissions (% of total fuel combustion) in Thailand in 1997 to that in 1999?
Provide a succinct answer. 1.06. What is the ratio of the CO2 emissions (% of total fuel combustion) in Benin in 1997 to that in 2000?
Ensure brevity in your answer.  0.9. What is the ratio of the CO2 emissions (% of total fuel combustion) of Lebanon in 1997 to that in 2000?
Keep it short and to the point. 0.96. What is the ratio of the CO2 emissions (% of total fuel combustion) of Moldova in 1997 to that in 2000?
Your answer should be very brief. 1.36. What is the ratio of the CO2 emissions (% of total fuel combustion) in Thailand in 1997 to that in 2000?
Make the answer very short. 1.1. What is the ratio of the CO2 emissions (% of total fuel combustion) of Benin in 1997 to that in 2001?
Your response must be concise. 1.02. What is the ratio of the CO2 emissions (% of total fuel combustion) in Lebanon in 1997 to that in 2001?
Provide a succinct answer. 1.11. What is the ratio of the CO2 emissions (% of total fuel combustion) of Moldova in 1997 to that in 2001?
Keep it short and to the point. 1.46. What is the ratio of the CO2 emissions (% of total fuel combustion) of Thailand in 1997 to that in 2001?
Offer a very short reply. 1.12. What is the ratio of the CO2 emissions (% of total fuel combustion) of Benin in 1997 to that in 2002?
Make the answer very short. 1. What is the ratio of the CO2 emissions (% of total fuel combustion) of Lebanon in 1997 to that in 2002?
Your answer should be compact. 1.11. What is the ratio of the CO2 emissions (% of total fuel combustion) of Thailand in 1997 to that in 2002?
Your answer should be very brief. 1.16. What is the ratio of the CO2 emissions (% of total fuel combustion) in Benin in 1997 to that in 2003?
Provide a short and direct response. 0.97. What is the ratio of the CO2 emissions (% of total fuel combustion) in Lebanon in 1997 to that in 2003?
Your response must be concise. 1.03. What is the ratio of the CO2 emissions (% of total fuel combustion) of Moldova in 1997 to that in 2003?
Your answer should be very brief. 0.93. What is the ratio of the CO2 emissions (% of total fuel combustion) of Thailand in 1997 to that in 2003?
Make the answer very short. 1.15. What is the ratio of the CO2 emissions (% of total fuel combustion) of Benin in 1998 to that in 1999?
Offer a very short reply. 0.98. What is the ratio of the CO2 emissions (% of total fuel combustion) of Lebanon in 1998 to that in 1999?
Your answer should be very brief. 1.11. What is the ratio of the CO2 emissions (% of total fuel combustion) of Moldova in 1998 to that in 1999?
Your answer should be very brief. 1.21. What is the ratio of the CO2 emissions (% of total fuel combustion) of Thailand in 1998 to that in 1999?
Ensure brevity in your answer.  1.01. What is the ratio of the CO2 emissions (% of total fuel combustion) in Benin in 1998 to that in 2000?
Your response must be concise. 0.96. What is the ratio of the CO2 emissions (% of total fuel combustion) in Lebanon in 1998 to that in 2000?
Make the answer very short. 1.05. What is the ratio of the CO2 emissions (% of total fuel combustion) of Moldova in 1998 to that in 2000?
Your answer should be compact. 1.13. What is the ratio of the CO2 emissions (% of total fuel combustion) in Thailand in 1998 to that in 2000?
Make the answer very short. 1.04. What is the ratio of the CO2 emissions (% of total fuel combustion) of Benin in 1998 to that in 2001?
Your answer should be compact. 1.08. What is the ratio of the CO2 emissions (% of total fuel combustion) of Lebanon in 1998 to that in 2001?
Your answer should be compact. 1.21. What is the ratio of the CO2 emissions (% of total fuel combustion) in Moldova in 1998 to that in 2001?
Provide a short and direct response. 1.21. What is the ratio of the CO2 emissions (% of total fuel combustion) in Thailand in 1998 to that in 2001?
Your answer should be compact. 1.06. What is the ratio of the CO2 emissions (% of total fuel combustion) in Benin in 1998 to that in 2002?
Your response must be concise. 1.06. What is the ratio of the CO2 emissions (% of total fuel combustion) of Lebanon in 1998 to that in 2002?
Make the answer very short. 1.21. What is the ratio of the CO2 emissions (% of total fuel combustion) in Moldova in 1998 to that in 2002?
Make the answer very short. 0.85. What is the ratio of the CO2 emissions (% of total fuel combustion) in Thailand in 1998 to that in 2002?
Ensure brevity in your answer.  1.1. What is the ratio of the CO2 emissions (% of total fuel combustion) in Benin in 1998 to that in 2003?
Your response must be concise. 1.03. What is the ratio of the CO2 emissions (% of total fuel combustion) in Lebanon in 1998 to that in 2003?
Provide a short and direct response. 1.12. What is the ratio of the CO2 emissions (% of total fuel combustion) of Moldova in 1998 to that in 2003?
Offer a very short reply. 0.78. What is the ratio of the CO2 emissions (% of total fuel combustion) of Thailand in 1998 to that in 2003?
Offer a terse response. 1.08. What is the ratio of the CO2 emissions (% of total fuel combustion) in Benin in 1999 to that in 2000?
Provide a succinct answer. 0.98. What is the ratio of the CO2 emissions (% of total fuel combustion) of Lebanon in 1999 to that in 2000?
Your answer should be very brief. 0.95. What is the ratio of the CO2 emissions (% of total fuel combustion) of Moldova in 1999 to that in 2000?
Provide a succinct answer. 0.93. What is the ratio of the CO2 emissions (% of total fuel combustion) of Thailand in 1999 to that in 2000?
Provide a succinct answer. 1.03. What is the ratio of the CO2 emissions (% of total fuel combustion) of Benin in 1999 to that in 2001?
Ensure brevity in your answer.  1.11. What is the ratio of the CO2 emissions (% of total fuel combustion) in Lebanon in 1999 to that in 2001?
Offer a terse response. 1.1. What is the ratio of the CO2 emissions (% of total fuel combustion) in Moldova in 1999 to that in 2001?
Your answer should be very brief. 1. What is the ratio of the CO2 emissions (% of total fuel combustion) of Thailand in 1999 to that in 2001?
Give a very brief answer. 1.06. What is the ratio of the CO2 emissions (% of total fuel combustion) in Benin in 1999 to that in 2002?
Your answer should be compact. 1.09. What is the ratio of the CO2 emissions (% of total fuel combustion) in Lebanon in 1999 to that in 2002?
Give a very brief answer. 1.09. What is the ratio of the CO2 emissions (% of total fuel combustion) of Moldova in 1999 to that in 2002?
Keep it short and to the point. 0.7. What is the ratio of the CO2 emissions (% of total fuel combustion) in Thailand in 1999 to that in 2002?
Your answer should be compact. 1.09. What is the ratio of the CO2 emissions (% of total fuel combustion) of Benin in 1999 to that in 2003?
Give a very brief answer. 1.05. What is the ratio of the CO2 emissions (% of total fuel combustion) in Lebanon in 1999 to that in 2003?
Your answer should be compact. 1.01. What is the ratio of the CO2 emissions (% of total fuel combustion) in Moldova in 1999 to that in 2003?
Provide a succinct answer. 0.64. What is the ratio of the CO2 emissions (% of total fuel combustion) of Thailand in 1999 to that in 2003?
Offer a terse response. 1.08. What is the ratio of the CO2 emissions (% of total fuel combustion) of Benin in 2000 to that in 2001?
Offer a very short reply. 1.13. What is the ratio of the CO2 emissions (% of total fuel combustion) in Lebanon in 2000 to that in 2001?
Provide a short and direct response. 1.16. What is the ratio of the CO2 emissions (% of total fuel combustion) of Moldova in 2000 to that in 2001?
Provide a short and direct response. 1.07. What is the ratio of the CO2 emissions (% of total fuel combustion) in Thailand in 2000 to that in 2001?
Offer a terse response. 1.03. What is the ratio of the CO2 emissions (% of total fuel combustion) in Benin in 2000 to that in 2002?
Your response must be concise. 1.11. What is the ratio of the CO2 emissions (% of total fuel combustion) of Lebanon in 2000 to that in 2002?
Provide a succinct answer. 1.15. What is the ratio of the CO2 emissions (% of total fuel combustion) in Moldova in 2000 to that in 2002?
Give a very brief answer. 0.75. What is the ratio of the CO2 emissions (% of total fuel combustion) in Thailand in 2000 to that in 2002?
Offer a very short reply. 1.06. What is the ratio of the CO2 emissions (% of total fuel combustion) of Benin in 2000 to that in 2003?
Keep it short and to the point. 1.08. What is the ratio of the CO2 emissions (% of total fuel combustion) in Lebanon in 2000 to that in 2003?
Offer a terse response. 1.07. What is the ratio of the CO2 emissions (% of total fuel combustion) in Moldova in 2000 to that in 2003?
Your response must be concise. 0.69. What is the ratio of the CO2 emissions (% of total fuel combustion) of Thailand in 2000 to that in 2003?
Ensure brevity in your answer.  1.05. What is the ratio of the CO2 emissions (% of total fuel combustion) in Benin in 2001 to that in 2002?
Make the answer very short. 0.98. What is the ratio of the CO2 emissions (% of total fuel combustion) in Lebanon in 2001 to that in 2002?
Make the answer very short. 0.99. What is the ratio of the CO2 emissions (% of total fuel combustion) of Moldova in 2001 to that in 2002?
Your answer should be very brief. 0.7. What is the ratio of the CO2 emissions (% of total fuel combustion) of Thailand in 2001 to that in 2002?
Give a very brief answer. 1.03. What is the ratio of the CO2 emissions (% of total fuel combustion) in Benin in 2001 to that in 2003?
Offer a terse response. 0.95. What is the ratio of the CO2 emissions (% of total fuel combustion) of Lebanon in 2001 to that in 2003?
Offer a terse response. 0.92. What is the ratio of the CO2 emissions (% of total fuel combustion) in Moldova in 2001 to that in 2003?
Provide a succinct answer. 0.64. What is the ratio of the CO2 emissions (% of total fuel combustion) in Thailand in 2001 to that in 2003?
Ensure brevity in your answer.  1.02. What is the ratio of the CO2 emissions (% of total fuel combustion) of Benin in 2002 to that in 2003?
Your answer should be very brief. 0.97. What is the ratio of the CO2 emissions (% of total fuel combustion) of Lebanon in 2002 to that in 2003?
Ensure brevity in your answer.  0.93. What is the ratio of the CO2 emissions (% of total fuel combustion) in Moldova in 2002 to that in 2003?
Your answer should be very brief. 0.91. What is the ratio of the CO2 emissions (% of total fuel combustion) of Thailand in 2002 to that in 2003?
Offer a very short reply. 0.99. What is the difference between the highest and the second highest CO2 emissions (% of total fuel combustion) of Benin?
Your answer should be very brief. 1.38. What is the difference between the highest and the second highest CO2 emissions (% of total fuel combustion) of Lebanon?
Ensure brevity in your answer.  1.3. What is the difference between the highest and the second highest CO2 emissions (% of total fuel combustion) of Moldova?
Your answer should be compact. 0.75. What is the difference between the highest and the second highest CO2 emissions (% of total fuel combustion) in Thailand?
Offer a terse response. 1.7. What is the difference between the highest and the lowest CO2 emissions (% of total fuel combustion) in Benin?
Ensure brevity in your answer.  7.56. What is the difference between the highest and the lowest CO2 emissions (% of total fuel combustion) of Lebanon?
Ensure brevity in your answer.  5.17. What is the difference between the highest and the lowest CO2 emissions (% of total fuel combustion) of Moldova?
Keep it short and to the point. 4.05. What is the difference between the highest and the lowest CO2 emissions (% of total fuel combustion) in Thailand?
Ensure brevity in your answer.  4.33. 